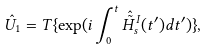Convert formula to latex. <formula><loc_0><loc_0><loc_500><loc_500>\hat { U } _ { 1 } = T \{ \exp ( i \int _ { 0 } ^ { t } \hat { \tilde { H } } ^ { I } _ { s } ( t ^ { \prime } ) d t ^ { \prime } ) \} ,</formula> 